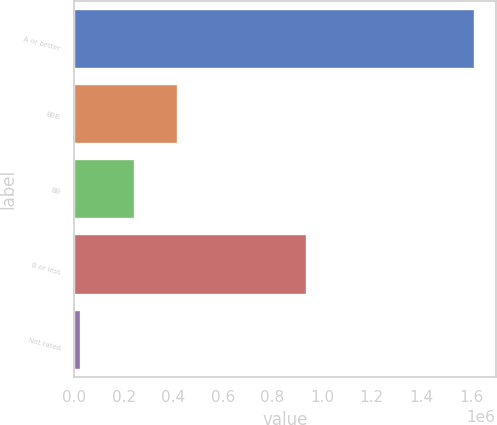Convert chart to OTSL. <chart><loc_0><loc_0><loc_500><loc_500><bar_chart><fcel>A or better<fcel>BBB<fcel>BB<fcel>B or less<fcel>Not rated<nl><fcel>1.61807e+06<fcel>418679<fcel>243793<fcel>939366<fcel>28035<nl></chart> 